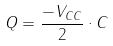<formula> <loc_0><loc_0><loc_500><loc_500>Q = \frac { - V _ { C C } } { 2 } \cdot C</formula> 